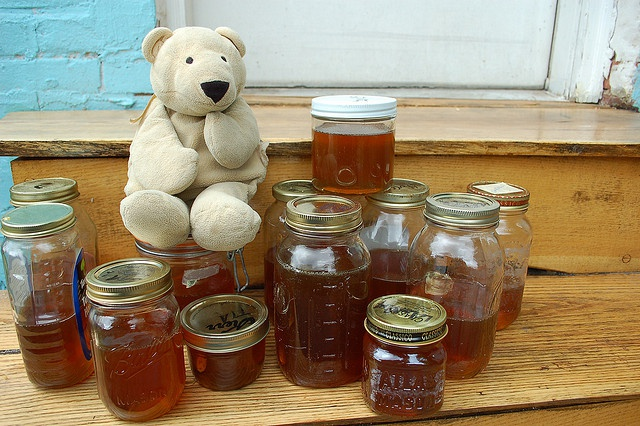Describe the objects in this image and their specific colors. I can see teddy bear in lightblue, beige, darkgray, and tan tones, bottle in lightblue, maroon, and gray tones, bottle in lightblue, maroon, darkgray, and gray tones, bottle in lightblue, maroon, gray, and tan tones, and bottle in lightblue, maroon, olive, and black tones in this image. 